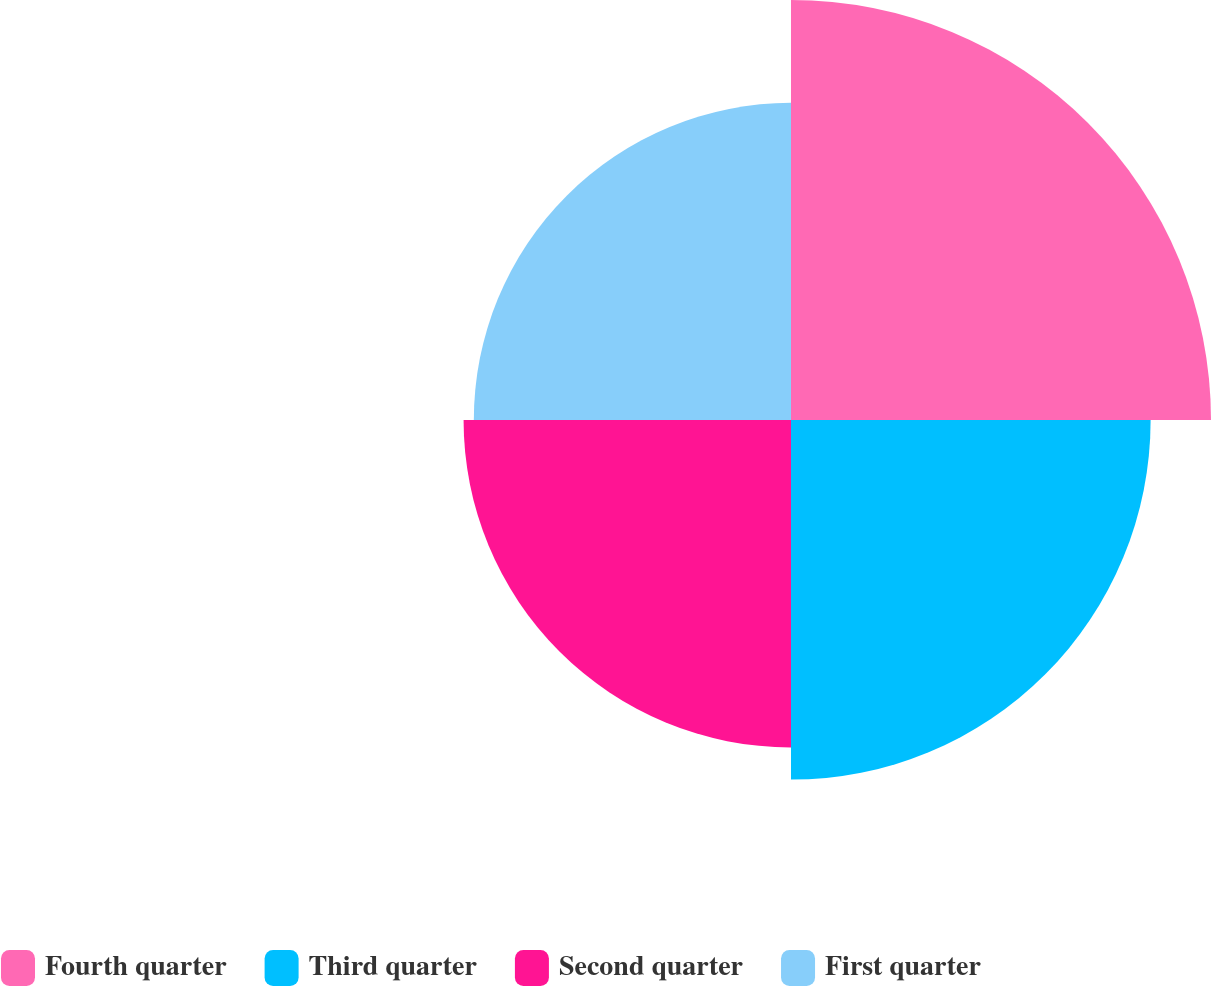<chart> <loc_0><loc_0><loc_500><loc_500><pie_chart><fcel>Fourth quarter<fcel>Third quarter<fcel>Second quarter<fcel>First quarter<nl><fcel>29.49%<fcel>25.25%<fcel>22.99%<fcel>22.27%<nl></chart> 